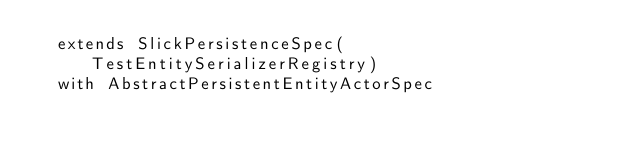Convert code to text. <code><loc_0><loc_0><loc_500><loc_500><_Scala_>  extends SlickPersistenceSpec(TestEntitySerializerRegistry)
  with AbstractPersistentEntityActorSpec
</code> 